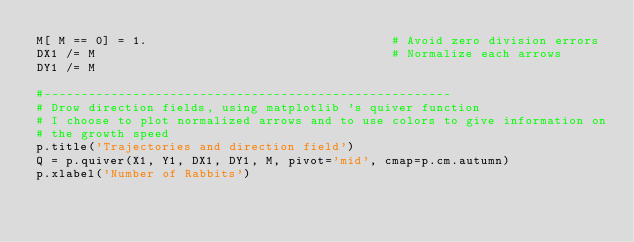<code> <loc_0><loc_0><loc_500><loc_500><_Python_>M[ M == 0] = 1.                                 # Avoid zero division errors 
DX1 /= M                                        # Normalize each arrows
DY1 /= M                                  

#-------------------------------------------------------
# Drow direction fields, using matplotlib 's quiver function
# I choose to plot normalized arrows and to use colors to give information on
# the growth speed
p.title('Trajectories and direction field')
Q = p.quiver(X1, Y1, DX1, DY1, M, pivot='mid', cmap=p.cm.autumn)
p.xlabel('Number of Rabbits')</code> 